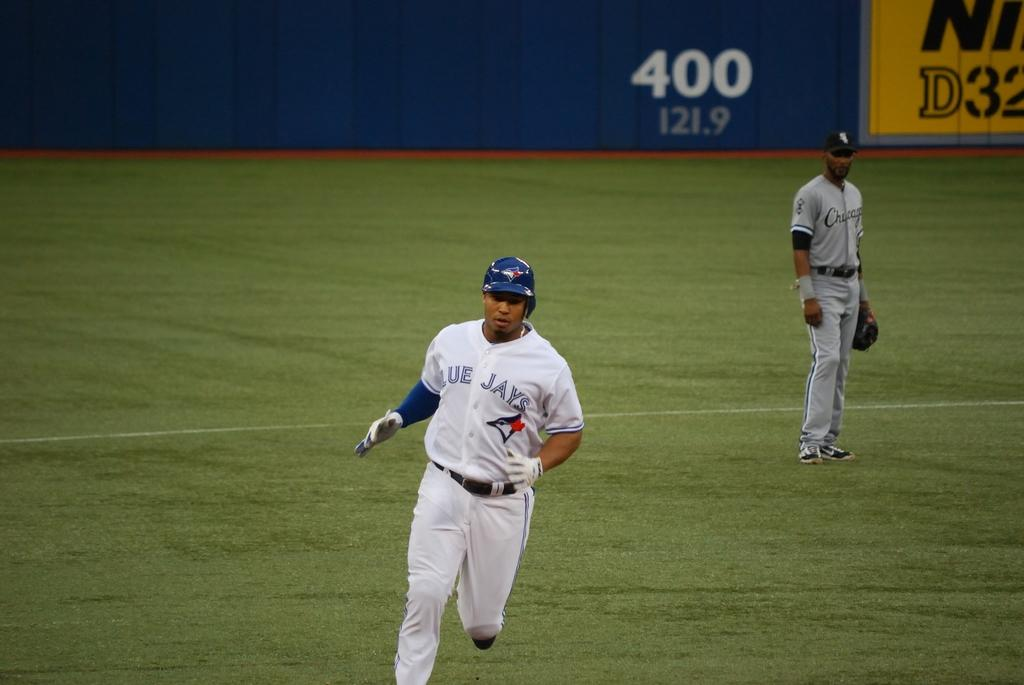<image>
Provide a brief description of the given image. Two Blue Jays baseball players are on th eplaying field in front of unreadable advertising hoardings. 